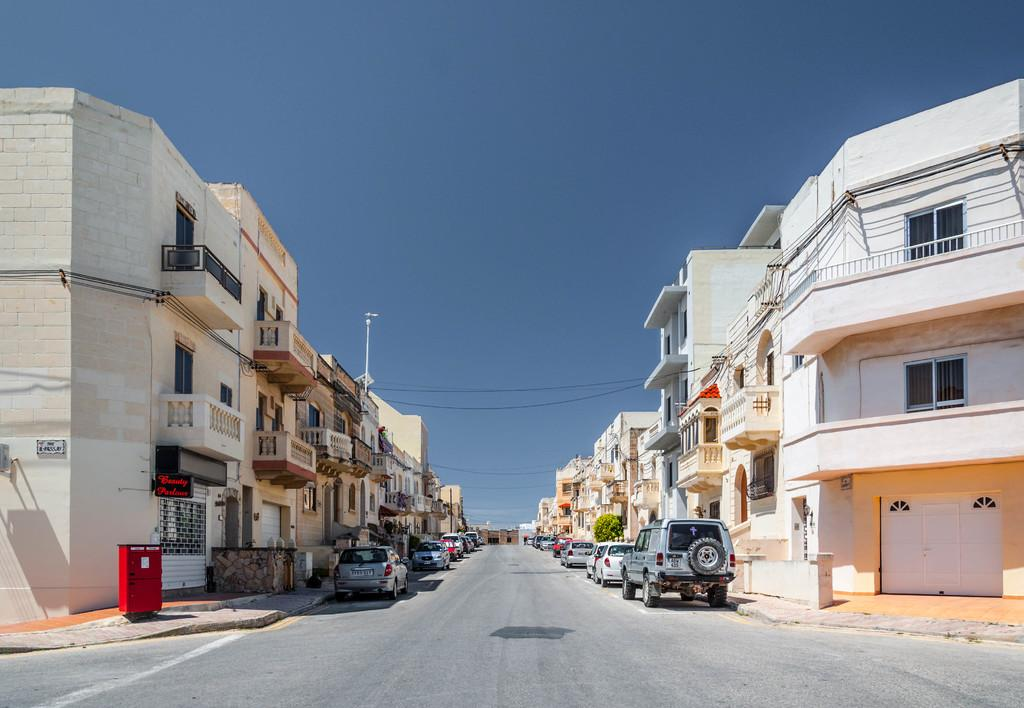What is located on the left side of the image? There are buildings on the left side of the image. What is located on the right side of the image? There are buildings on the right side of the image. What else can be seen in the image besides buildings? There are vehicles and a road visible in the image. What is visible at the top of the image? The sky is visible at the top of the image. What type of flag is being gripped by the water in the image? There is no flag or water present in the image; it features buildings, vehicles, and a road. How does the water grip the flag in the image? There is no water or flag present in the image, so it is not possible to answer this question. 